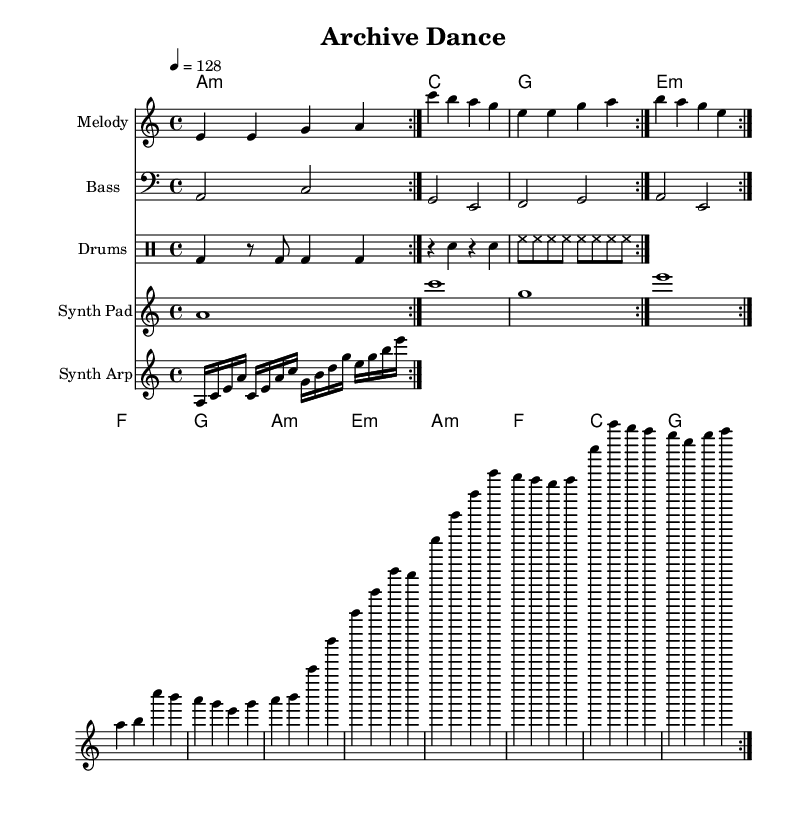What is the key signature of this music? The key signature indicates a one flat, which signifies that the piece is in A minor. The key is marked at the beginning of the score right after the \key declaration.
Answer: A minor What is the time signature of this music? The time signature is noted as 4/4, which means there are four beats in each measure and the quarter note gets one beat. This is also indicated at the start of the score with the \time declaration.
Answer: 4/4 What is the tempo marking of this piece? The tempo is indicated by the marking "4 = 128", which is commonly found at the beginning of the score. It specifies that the beat should be played at a tempo of 128 beats per minute.
Answer: 128 How many times does the melody repeat in total? The melody has a repeat structure where it is indicated to repeat volta 2, meaning that it plays through twice in total. Each volta section is clearly marked which indicates that the first section is to be played again.
Answer: 2 What type of rhythmic pattern is used in the drums? The drum part shows a consistent pattern with kick drum hits on the strong beats and snare on alternating beats. The repeated pattern is evident in the drum staff with specified symbols, denoting the rhythm.
Answer: Steady What is the structure of the song in terms of sections? The song consists of a verse, pre-chorus, and chorus, each of which is identifiable by different melody sections and marked accordingly in the sheet music. This typical structure is common in K-Pop songs as they emphasize distinct parts.
Answer: Verse, Pre-Chorus, Chorus What is the name of the song based on the header? The title, "Archive Dance", is noted in the header of the score and serves to identify the piece and its thematic focus on energetic dance with a knowledge preservation aspect.
Answer: Archive Dance 